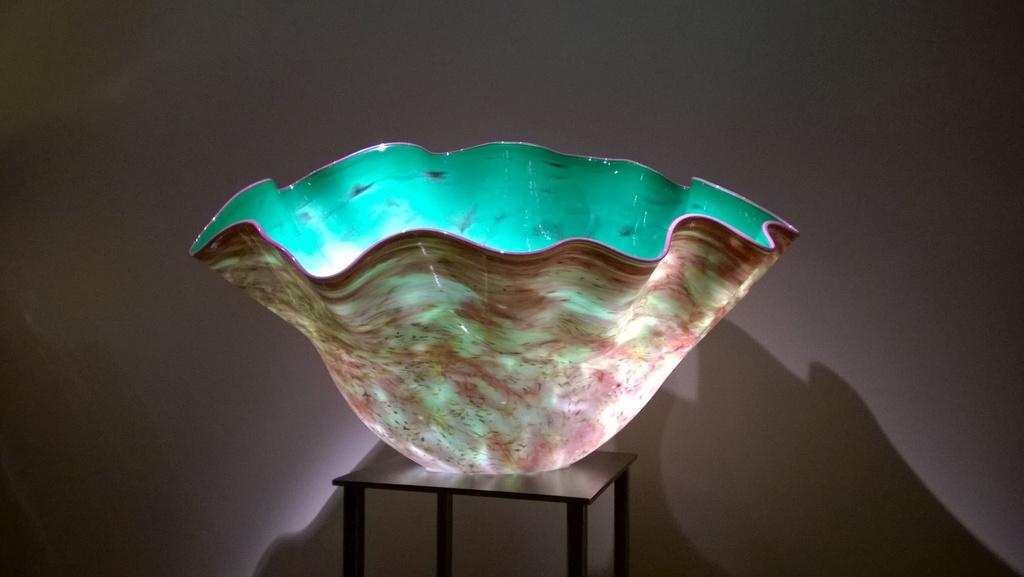What can be seen on the side table in the image? There is a decoration on a side table in the image. What type of animal is laughing in the image? There is no animal present in the image, and therefore no one is laughing. 